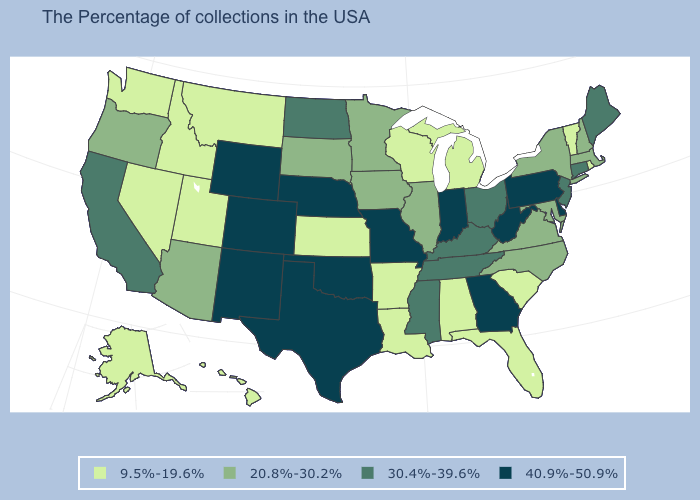Does Nebraska have the highest value in the MidWest?
Answer briefly. Yes. How many symbols are there in the legend?
Write a very short answer. 4. What is the value of Rhode Island?
Short answer required. 9.5%-19.6%. Does New Mexico have the highest value in the USA?
Answer briefly. Yes. Among the states that border Montana , which have the lowest value?
Short answer required. Idaho. What is the highest value in states that border Georgia?
Write a very short answer. 30.4%-39.6%. Does the first symbol in the legend represent the smallest category?
Give a very brief answer. Yes. What is the lowest value in states that border Massachusetts?
Short answer required. 9.5%-19.6%. Name the states that have a value in the range 30.4%-39.6%?
Concise answer only. Maine, Connecticut, New Jersey, Ohio, Kentucky, Tennessee, Mississippi, North Dakota, California. Which states have the highest value in the USA?
Keep it brief. Delaware, Pennsylvania, West Virginia, Georgia, Indiana, Missouri, Nebraska, Oklahoma, Texas, Wyoming, Colorado, New Mexico. Which states have the lowest value in the South?
Quick response, please. South Carolina, Florida, Alabama, Louisiana, Arkansas. Does New Mexico have the highest value in the USA?
Answer briefly. Yes. Name the states that have a value in the range 40.9%-50.9%?
Short answer required. Delaware, Pennsylvania, West Virginia, Georgia, Indiana, Missouri, Nebraska, Oklahoma, Texas, Wyoming, Colorado, New Mexico. Does Virginia have the same value as South Dakota?
Short answer required. Yes. 